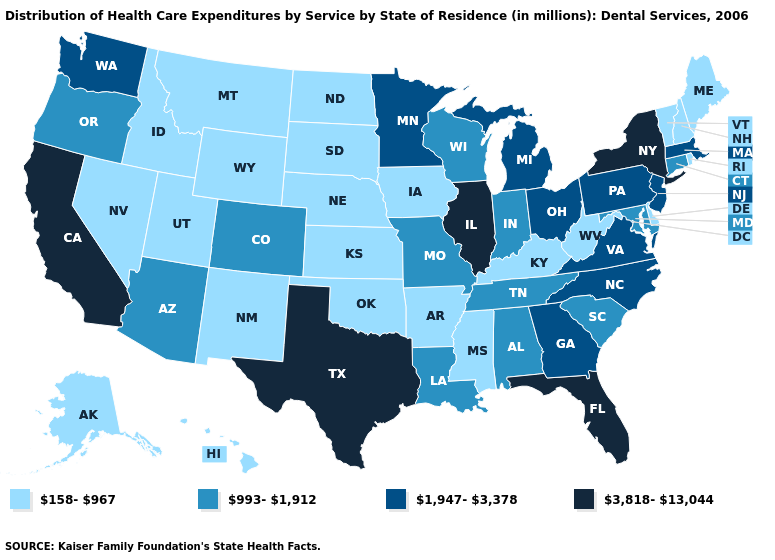Name the states that have a value in the range 3,818-13,044?
Quick response, please. California, Florida, Illinois, New York, Texas. How many symbols are there in the legend?
Give a very brief answer. 4. Which states hav the highest value in the MidWest?
Keep it brief. Illinois. What is the value of Alaska?
Give a very brief answer. 158-967. Does the map have missing data?
Answer briefly. No. Name the states that have a value in the range 1,947-3,378?
Concise answer only. Georgia, Massachusetts, Michigan, Minnesota, New Jersey, North Carolina, Ohio, Pennsylvania, Virginia, Washington. What is the value of Maryland?
Be succinct. 993-1,912. Name the states that have a value in the range 993-1,912?
Short answer required. Alabama, Arizona, Colorado, Connecticut, Indiana, Louisiana, Maryland, Missouri, Oregon, South Carolina, Tennessee, Wisconsin. Which states have the highest value in the USA?
Quick response, please. California, Florida, Illinois, New York, Texas. What is the value of California?
Answer briefly. 3,818-13,044. What is the value of Utah?
Keep it brief. 158-967. Name the states that have a value in the range 3,818-13,044?
Keep it brief. California, Florida, Illinois, New York, Texas. What is the lowest value in the USA?
Short answer required. 158-967. What is the lowest value in the South?
Concise answer only. 158-967. Does Alabama have the lowest value in the USA?
Write a very short answer. No. 